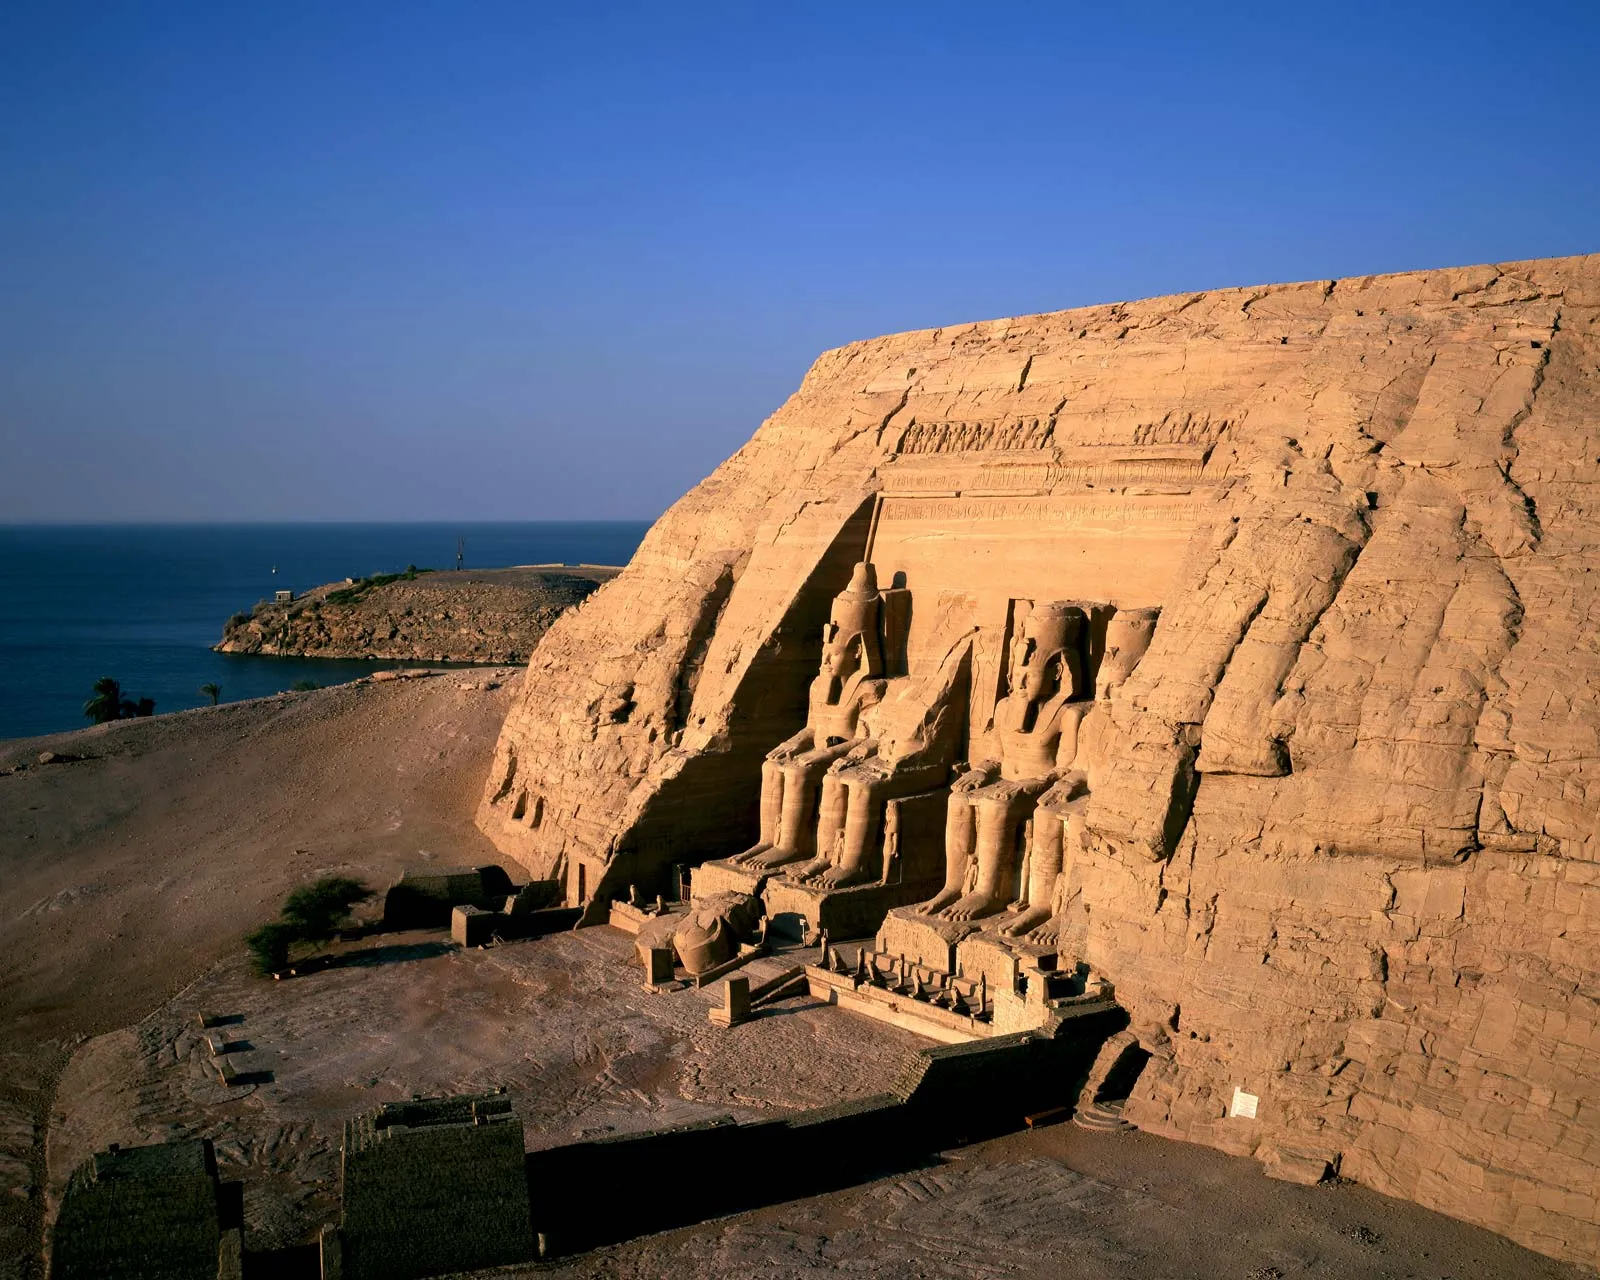If this temple could tell a story, what tale would it narrate about its existence? If the Abu Simbel temple could narrate its own story, it would tell a tale of grandeur and devotion spanning millennia. It would begin with the vision of Pharaoh Ramesses II, who sought to immortalize his glory and divine favor. The temple would recall the painstaking efforts of thousands of workers, from skilled artisans to laborers, who carved its massive statues and intricate hieroglyphs. It would speak of festivals and rituals held in its hallowed halls, and the twice-yearly solar alignment, a magical event symbolizing cosmic harmony. The temple would also recount the modern chapter of its life—its daring rescue and relocation as waters from the Aswan High Dam threatened to submerge it, an orchestrated dance of technology and reverence by people from across the globe coming together to save this ancient treasure. This story is one of resilience, craftsmanship, and the eternal desire of humanity to connect with the divine. Can you create a short fiction about an adventure that takes place around this temple? In the quiet whisper of the Egyptian dawn, a young archaeologist named Layla discovered an ancient scroll hidden deep within the sands near the Abu Simbel temple. The scroll hinted at a hidden chamber beneath the temple, believed to house the legendary 'Eye of Ra,' a jewel said to hold unimaginable power. Driven by curiosity and a sense of adventure, Layla braved the scorching desert and the hidden perils within the temple's depths. Alongside her mentor, Dr. Hassan, and a team of local guides, they deciphered hieroglyphs and navigated treacherous passageways. Each step brought them closer to the jewel and the ancient puzzles guarding it. Their journey was fraught with danger— collapsing structures, hidden traps, and the looming shadow of a rival archaeologist intent on seizing the jewel for himself. In the climactic moment, Layla and Dr. Hassan unearthed the chamber and gazed upon the 'Eye of Ra,' only to realize that its true power was not material but an ancient wisdom, a message of peace and unity inscribed by the ancients. Their discovery reshaped the course of Egyptology, revealing deeper insights into the connection between humanity and the divine. 